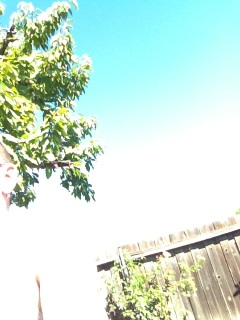What kind of weather conditions are implied by this image? The sky in the image is clear and predominantly blue, with no visible clouds, indicating that the weather is likely sunny and clear, which is typical of a fair weather condition. 